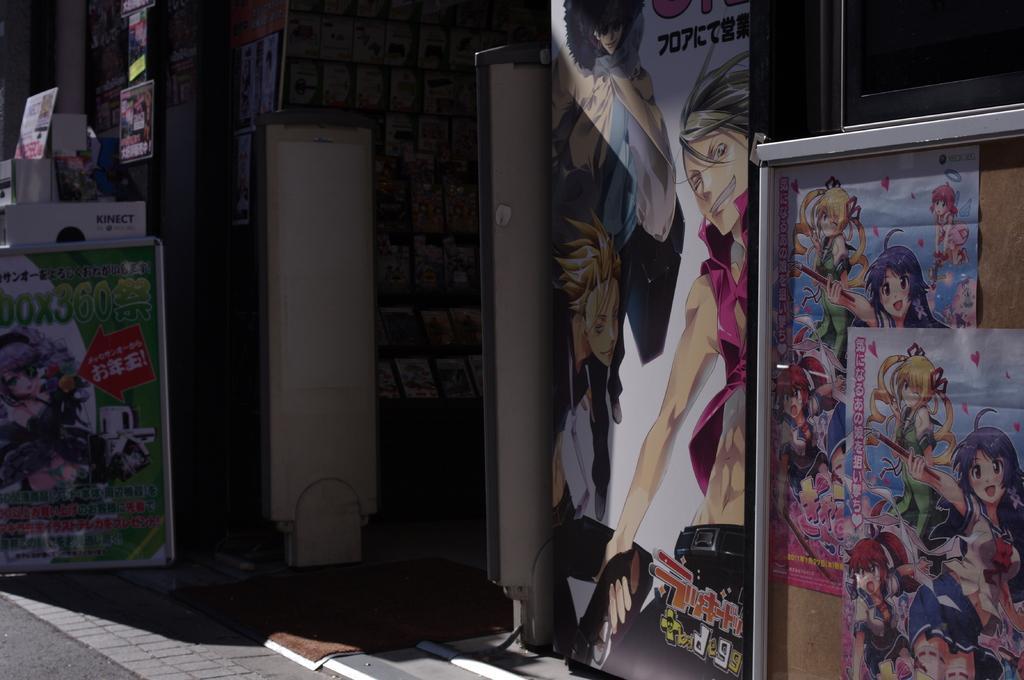Please provide a concise description of this image. In this image I can see many boards and mat in-front of the store. I can see few boards attached to the store. Inside of the store I can see few objects. These boards are colorful. 